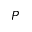<formula> <loc_0><loc_0><loc_500><loc_500>P</formula> 